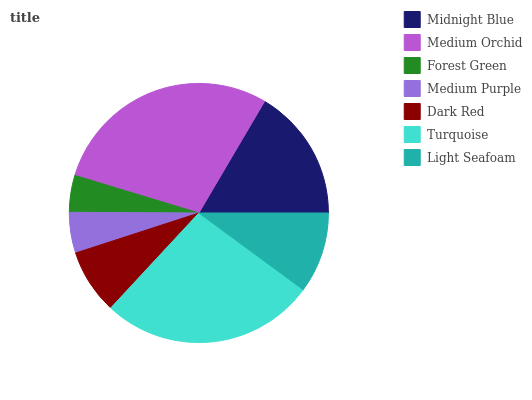Is Forest Green the minimum?
Answer yes or no. Yes. Is Medium Orchid the maximum?
Answer yes or no. Yes. Is Medium Orchid the minimum?
Answer yes or no. No. Is Forest Green the maximum?
Answer yes or no. No. Is Medium Orchid greater than Forest Green?
Answer yes or no. Yes. Is Forest Green less than Medium Orchid?
Answer yes or no. Yes. Is Forest Green greater than Medium Orchid?
Answer yes or no. No. Is Medium Orchid less than Forest Green?
Answer yes or no. No. Is Light Seafoam the high median?
Answer yes or no. Yes. Is Light Seafoam the low median?
Answer yes or no. Yes. Is Dark Red the high median?
Answer yes or no. No. Is Forest Green the low median?
Answer yes or no. No. 